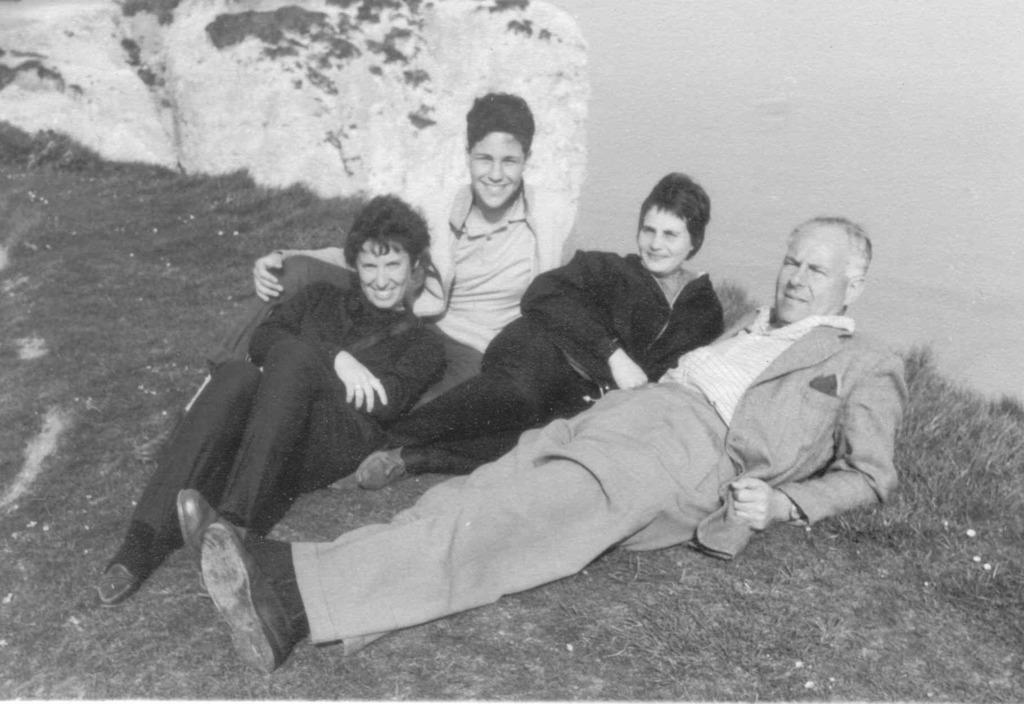In one or two sentences, can you explain what this image depicts? This is a black and white image, in this image there are people laying on a grassland, in the background there is a wall. 